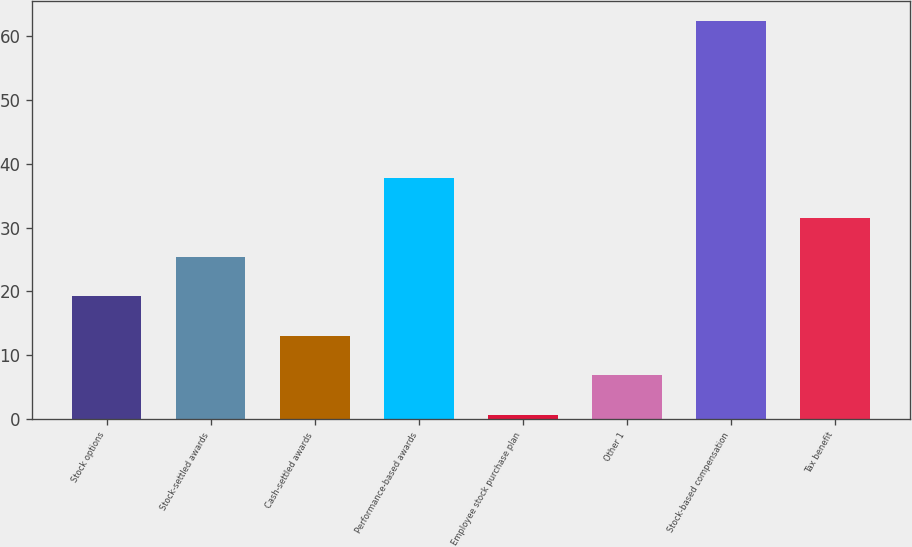<chart> <loc_0><loc_0><loc_500><loc_500><bar_chart><fcel>Stock options<fcel>Stock-settled awards<fcel>Cash-settled awards<fcel>Performance-based awards<fcel>Employee stock purchase plan<fcel>Other 1<fcel>Stock-based compensation<fcel>Tax benefit<nl><fcel>19.21<fcel>25.38<fcel>13.04<fcel>37.72<fcel>0.7<fcel>6.87<fcel>62.4<fcel>31.55<nl></chart> 